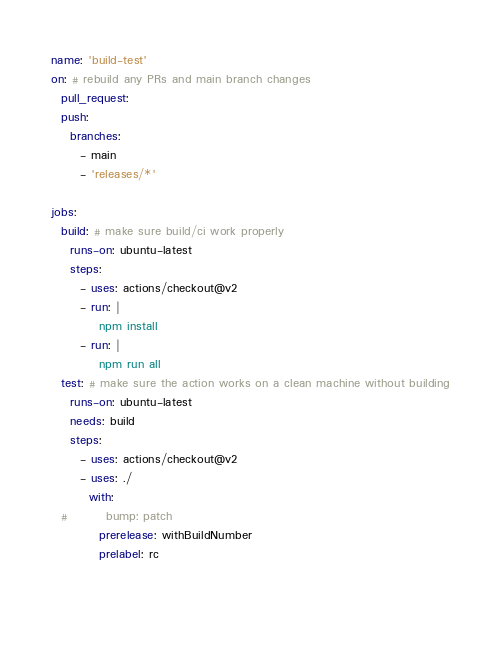<code> <loc_0><loc_0><loc_500><loc_500><_YAML_>name: 'build-test'
on: # rebuild any PRs and main branch changes
  pull_request:
  push:
    branches:
      - main
      - 'releases/*'

jobs:
  build: # make sure build/ci work properly
    runs-on: ubuntu-latest
    steps:
      - uses: actions/checkout@v2
      - run: |
          npm install
      - run: |
          npm run all
  test: # make sure the action works on a clean machine without building
    runs-on: ubuntu-latest
    needs: build
    steps:
      - uses: actions/checkout@v2
      - uses: ./
        with:
  #        bump: patch
          prerelease: withBuildNumber
          prelabel: rc

          
</code> 